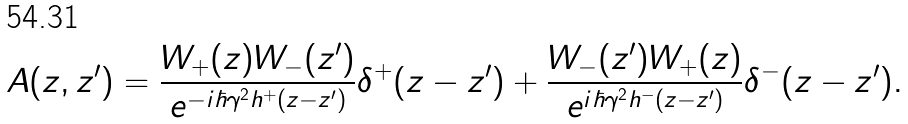Convert formula to latex. <formula><loc_0><loc_0><loc_500><loc_500>A ( z , z ^ { \prime } ) = \frac { W _ { + } ( z ) W _ { - } ( z ^ { \prime } ) } { e ^ { - i \hbar { \gamma } ^ { 2 } h ^ { + } ( z - z ^ { \prime } ) } } \delta ^ { + } ( z - z ^ { \prime } ) + \frac { W _ { - } ( z ^ { \prime } ) W _ { + } ( z ) } { e ^ { i \hbar { \gamma } ^ { 2 } h ^ { - } ( z - z ^ { \prime } ) } } \delta ^ { - } ( z - z ^ { \prime } ) .</formula> 